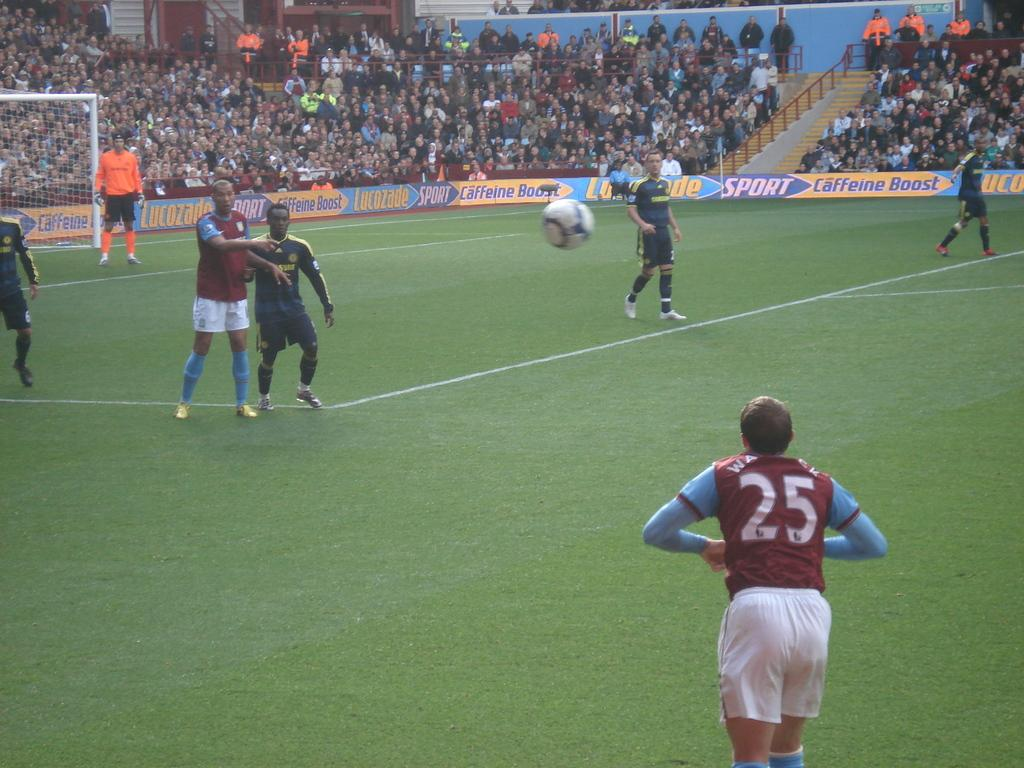<image>
Present a compact description of the photo's key features. A person wearing a jersey with the number 25 is standing on a soccer field. 